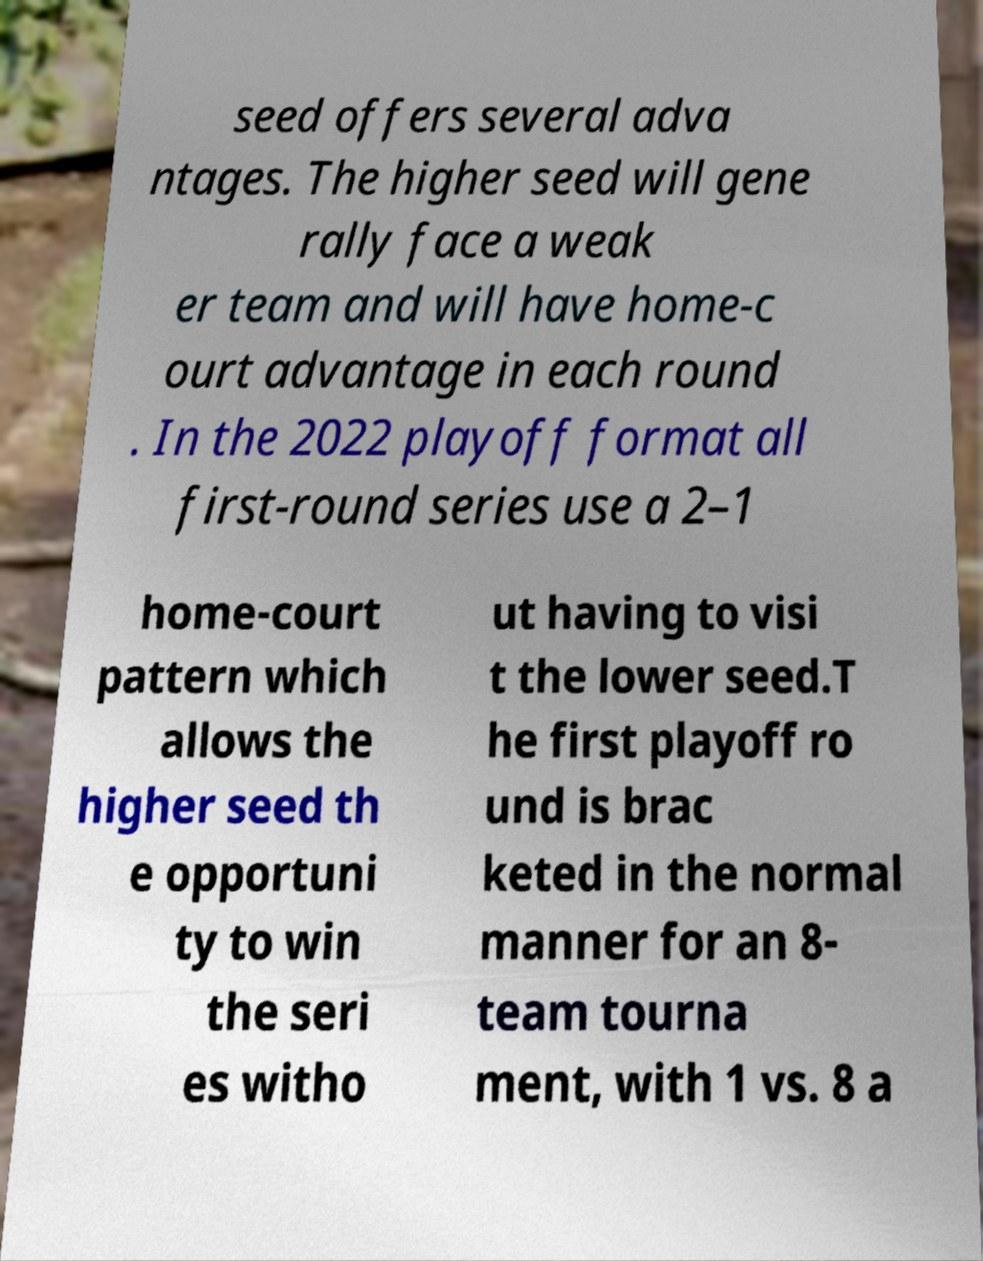Can you accurately transcribe the text from the provided image for me? seed offers several adva ntages. The higher seed will gene rally face a weak er team and will have home-c ourt advantage in each round . In the 2022 playoff format all first-round series use a 2–1 home-court pattern which allows the higher seed th e opportuni ty to win the seri es witho ut having to visi t the lower seed.T he first playoff ro und is brac keted in the normal manner for an 8- team tourna ment, with 1 vs. 8 a 